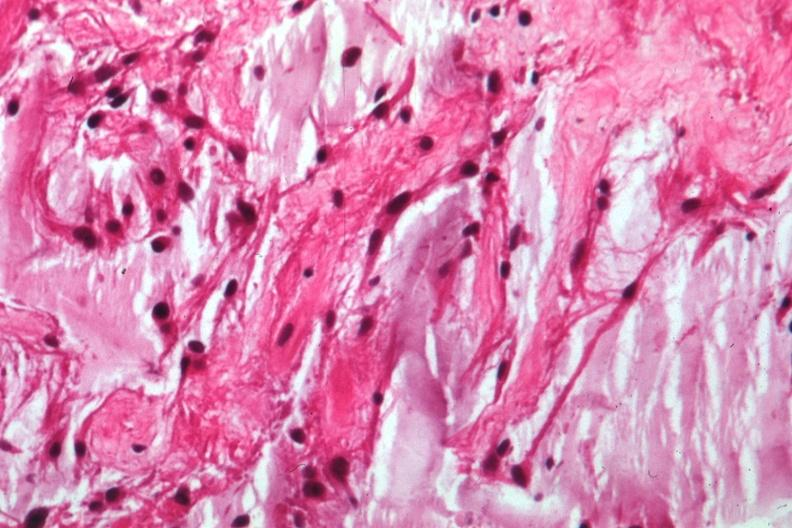what is present?
Answer the question using a single word or phrase. Optic nerve 